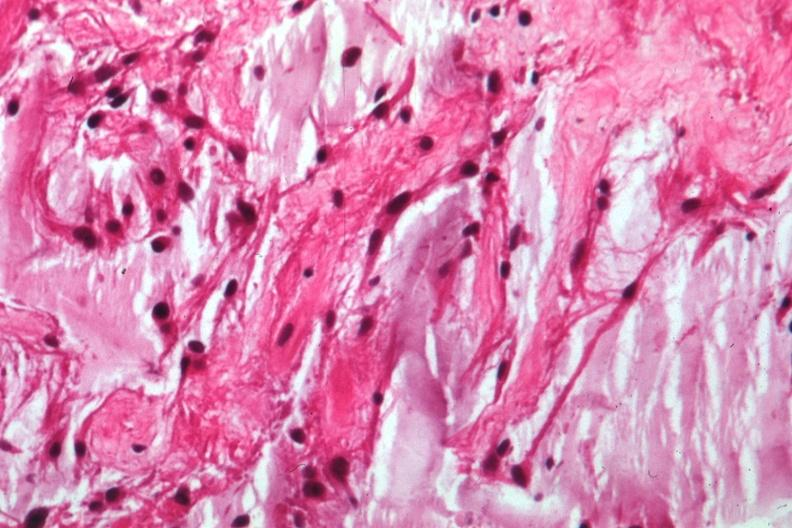what is present?
Answer the question using a single word or phrase. Optic nerve 